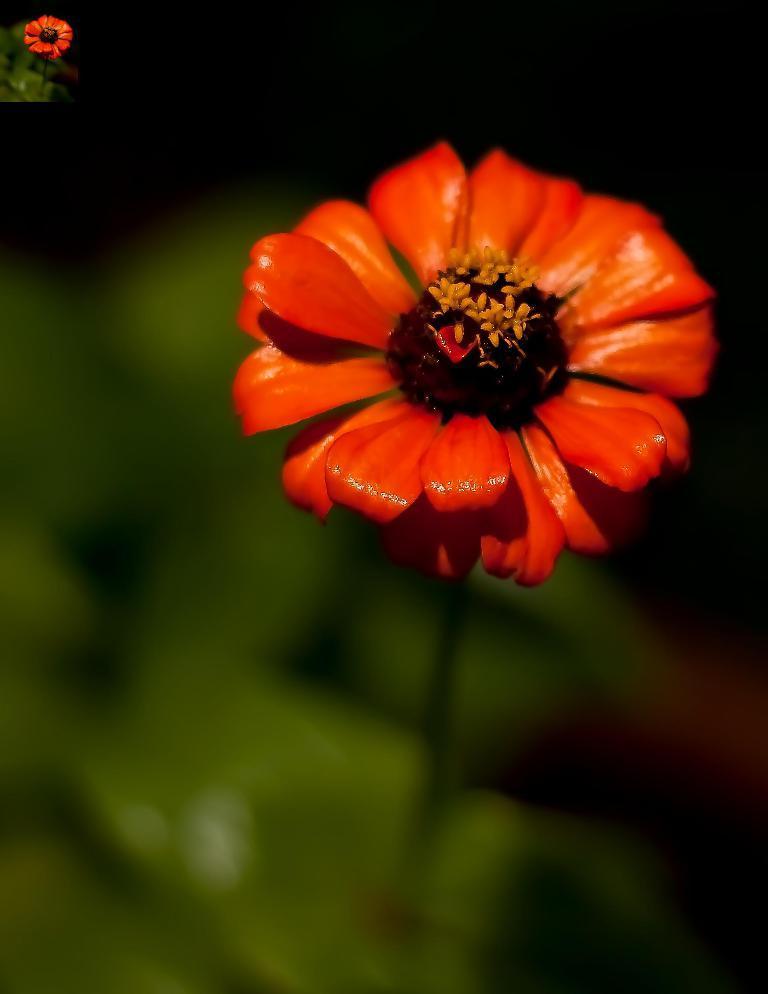How would you summarize this image in a sentence or two? In this image there is a flower. 